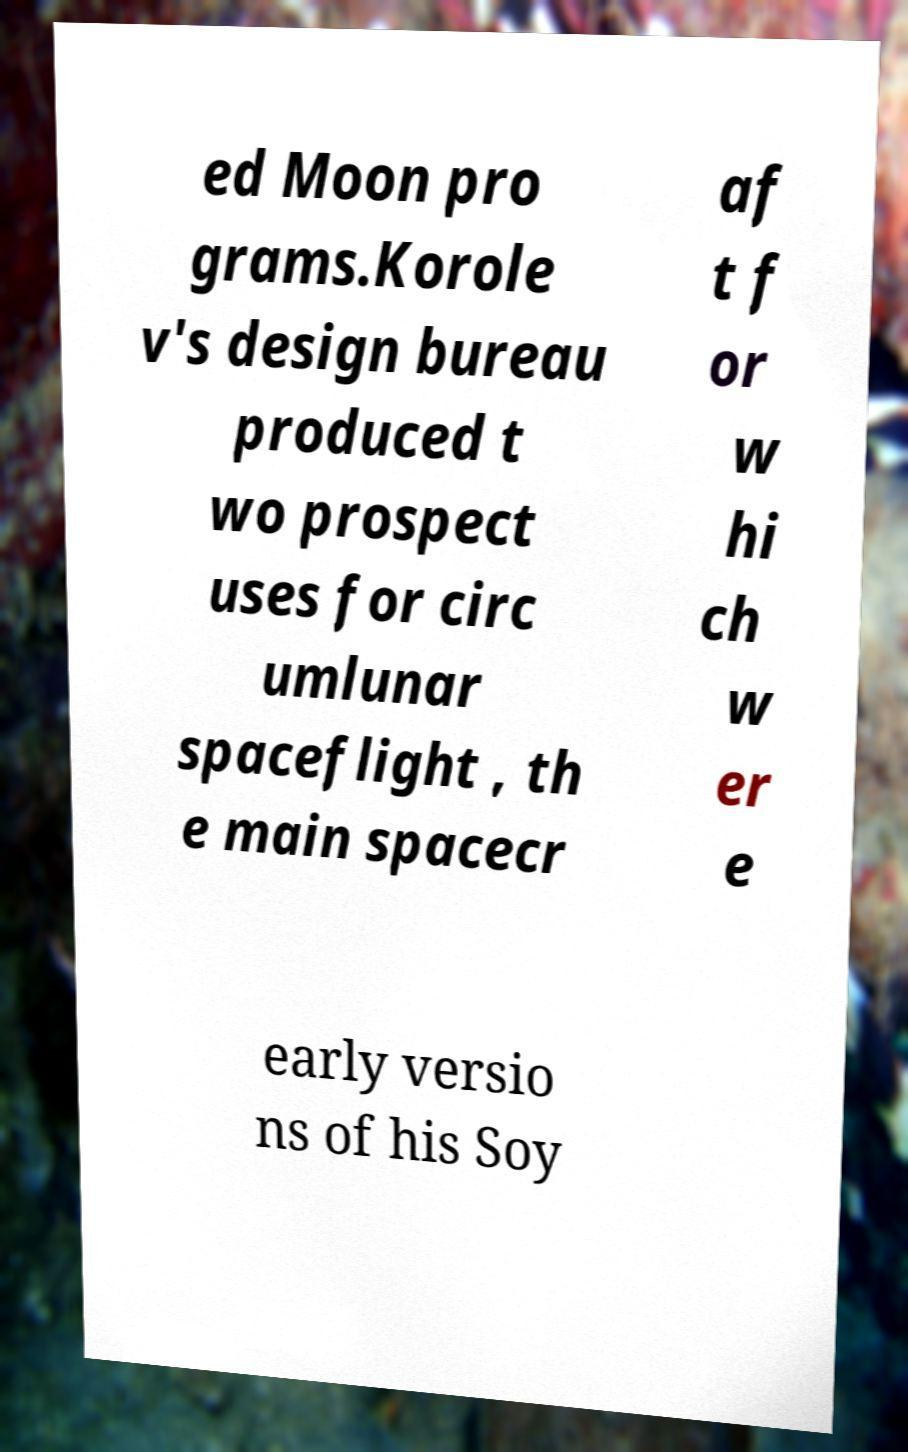There's text embedded in this image that I need extracted. Can you transcribe it verbatim? ed Moon pro grams.Korole v's design bureau produced t wo prospect uses for circ umlunar spaceflight , th e main spacecr af t f or w hi ch w er e early versio ns of his Soy 